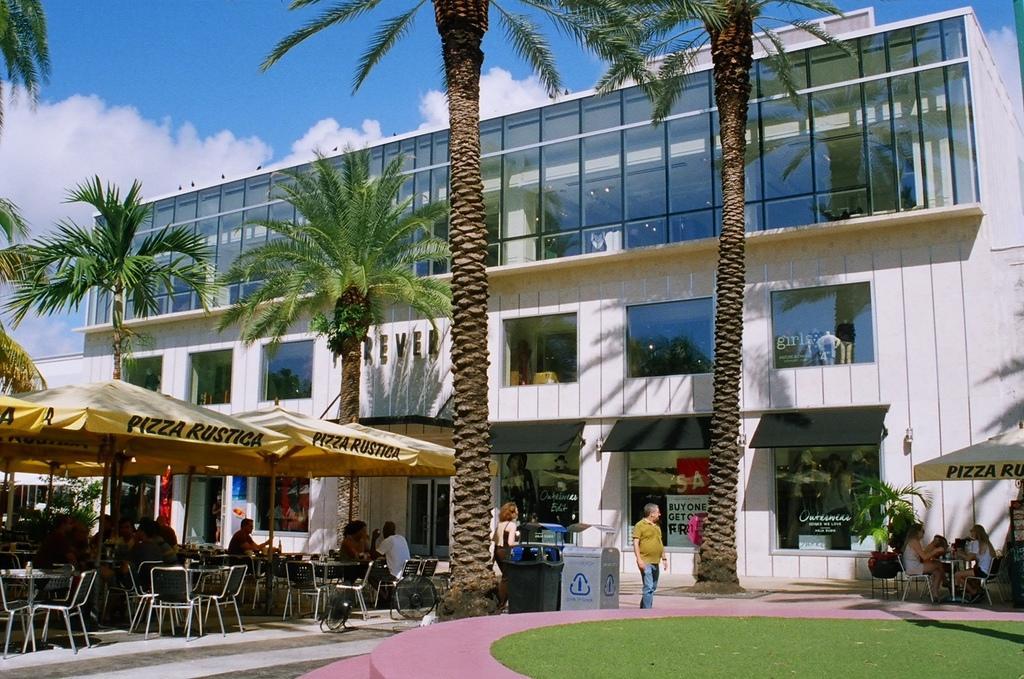Describe this image in one or two sentences. As we can see in the image there is grass, tents, buildings, windows, trees, sky, clouds, chairs, few people here and there and tables. On the right side there is an umbrella. 